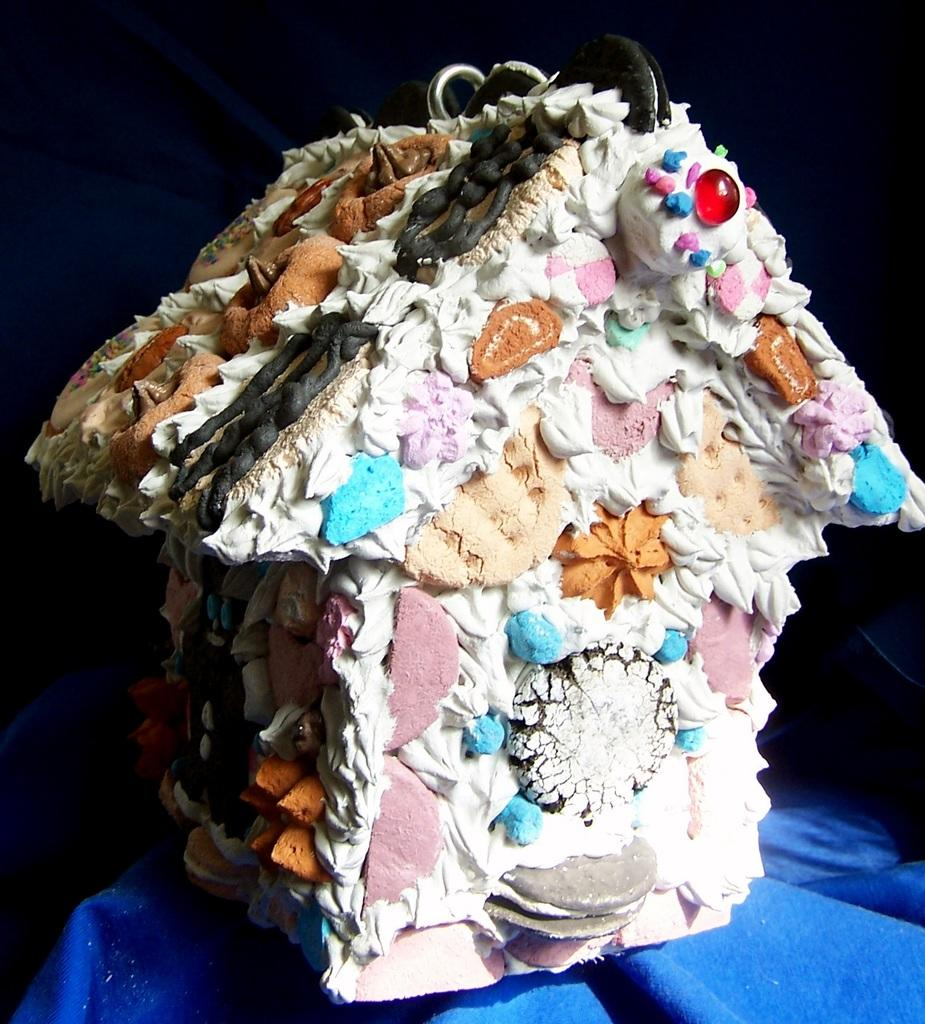What is the main subject of the image? There is a white color cake in the shape of a house in the image. Can you describe the color of the cake? The cake is white in color. What shape is the cake in the image? The cake is in the shape of a house. What is present in the foreground of the image? There is a blue color object in the foreground of the image. What type of quartz can be seen in the image? There is no quartz present in the image. What system is responsible for the creation of the cake in the image? The image does not provide information about the system responsible for creating the cake. 